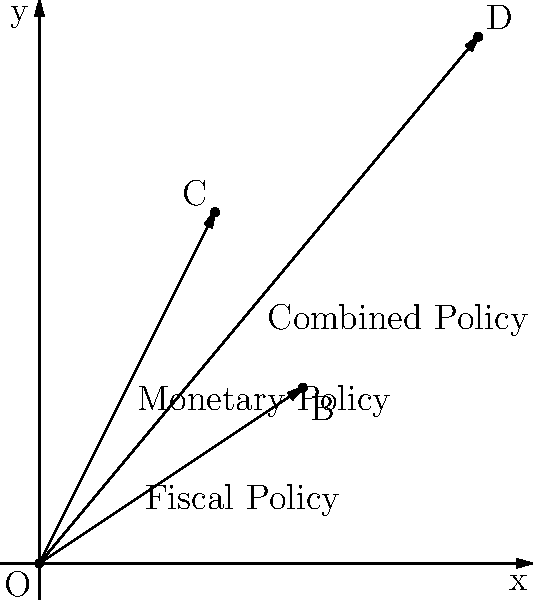The government is considering a combination of fiscal and monetary policies to achieve economic stability. The fiscal policy vector is represented by $\vec{OB} = (3, 2)$, and the monetary policy vector is represented by $\vec{OC} = (2, 4)$. What is the magnitude of the combined policy vector $\vec{OD}$, and how does it compare to the individual policy vectors? To solve this problem, we'll follow these steps:

1. Find the combined policy vector $\vec{OD}$ using vector addition:
   $\vec{OD} = \vec{OB} + \vec{OC} = (3, 2) + (2, 4) = (5, 6)$

2. Calculate the magnitude of the combined policy vector $\vec{OD}$:
   $|\vec{OD}| = \sqrt{5^2 + 6^2} = \sqrt{25 + 36} = \sqrt{61} \approx 7.81$

3. Calculate the magnitudes of the individual policy vectors:
   $|\vec{OB}| = \sqrt{3^2 + 2^2} = \sqrt{9 + 4} = \sqrt{13} \approx 3.61$
   $|\vec{OC}| = \sqrt{2^2 + 4^2} = \sqrt{4 + 16} = \sqrt{20} \approx 4.47$

4. Compare the magnitudes:
   The combined policy vector $\vec{OD}$ has a magnitude of approximately 7.81, which is greater than both individual policy vectors $\vec{OB}$ (3.61) and $\vec{OC}$ (4.47).

5. Interpret the result:
   The combined policy vector represents a stronger overall economic policy direction compared to either fiscal or monetary policy alone. This suggests that a balanced approach using both fiscal and monetary tools may lead to greater economic stability.
Answer: $|\vec{OD}| \approx 7.81$, greater than both individual policy vectors. 